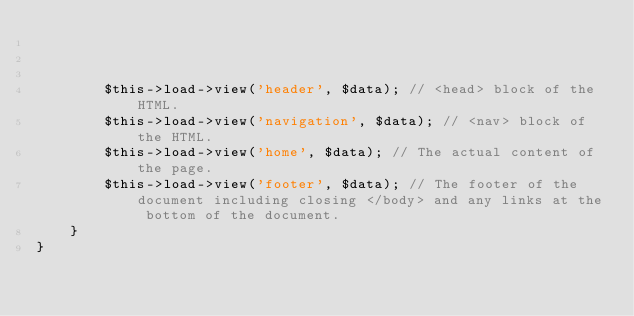Convert code to text. <code><loc_0><loc_0><loc_500><loc_500><_PHP_>


		$this->load->view('header', $data); // <head> block of the HTML.
		$this->load->view('navigation', $data); // <nav> block of the HTML.
		$this->load->view('home', $data); // The actual content of the page.
		$this->load->view('footer', $data); // The footer of the document including closing </body> and any links at the bottom of the document.
	}
}
</code> 